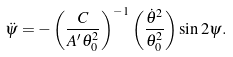<formula> <loc_0><loc_0><loc_500><loc_500>\ddot { \psi } = - \left ( \frac { C } { A ^ { \prime } \theta _ { 0 } ^ { 2 } } \right ) ^ { - 1 } \left ( \frac { { \dot { \theta } } ^ { 2 } } { \theta _ { 0 } ^ { 2 } } \right ) \sin 2 \psi .</formula> 